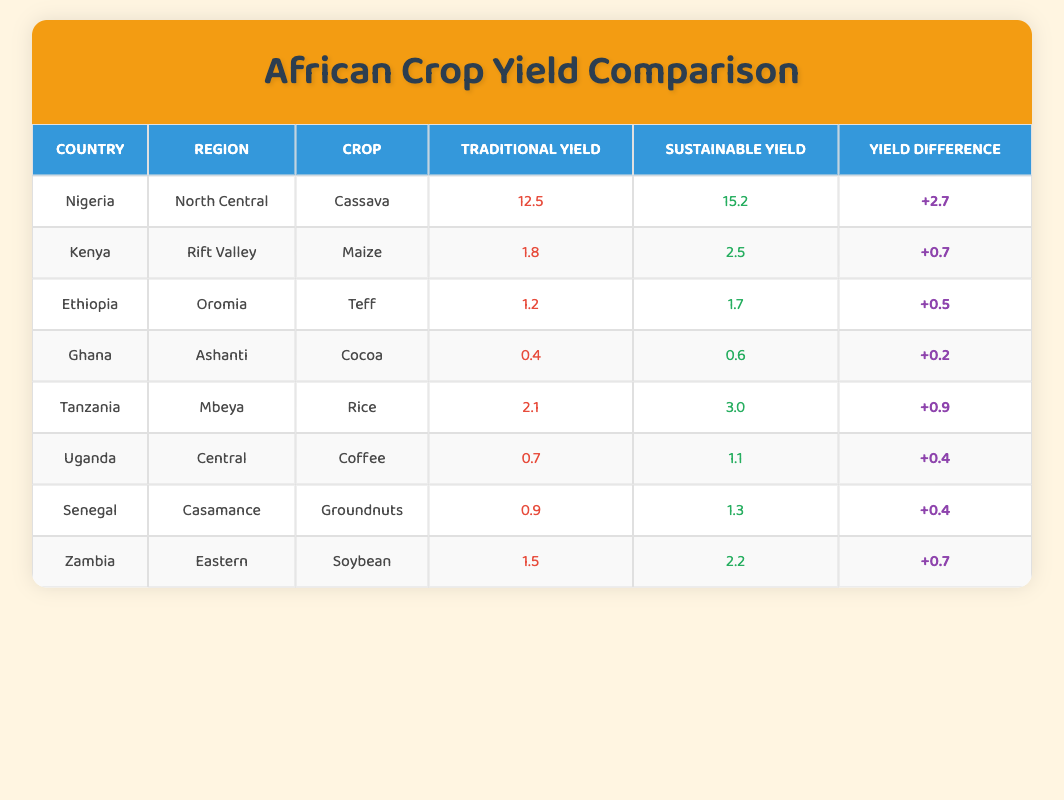What is the sustainable yield of Cassava in Nigeria? The table shows that the sustainable yield of Cassava in Nigeria is 15.2.
Answer: 15.2 Which crop has the highest traditional yield in the table? Comparing all traditional yields, Cassava in Nigeria has the highest yield at 12.5.
Answer: Cassava True or False: The yield difference for Cocoa in Ghana is greater than 0.5. The table indicates a yield difference of +0.2 for Cocoa in Ghana, which is not greater than 0.5.
Answer: False What is the average sustainable yield for all crops listed? Calculating the sustainable yields: (15.2 + 2.5 + 1.7 + 0.6 + 3.0 + 1.1 + 1.3 + 2.2) = 27.6, and there are 8 crops, so average = 27.6 / 8 = 3.45.
Answer: 3.45 Which region produces the highest yield difference, and what is that difference? Analyzing the yield differences, the highest is seen in Nigeria for Cassava with a difference of +2.7.
Answer: Nigeria, +2.7 How much greater is the yield of sustainable Rice in Tanzania compared to traditional Rice? The sustainable yield for Rice in Tanzania is 3.0 and the traditional yield is 2.1, the difference is 3.0 - 2.1 = 0.9.
Answer: 0.9 True or False: Coffee yields more with sustainable farming methods than with traditional methods in Uganda. The table shows that sustainable Coffee yield is 1.1, which is greater than the traditional yield of 0.7.
Answer: True What is the total yield difference when summing up all differences for all crops? Summing up all yield differences: 2.7 + 0.7 + 0.5 + 0.2 + 0.9 + 0.4 + 0.4 + 0.7 = 6.5.
Answer: 6.5 